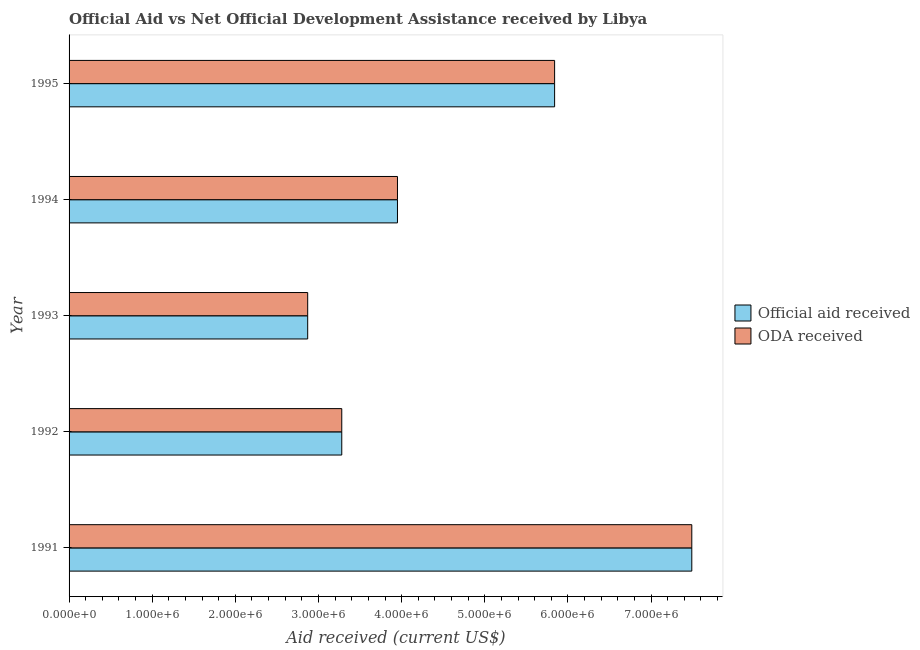How many groups of bars are there?
Give a very brief answer. 5. Are the number of bars per tick equal to the number of legend labels?
Your answer should be very brief. Yes. Are the number of bars on each tick of the Y-axis equal?
Your answer should be very brief. Yes. How many bars are there on the 3rd tick from the top?
Your answer should be very brief. 2. What is the oda received in 1995?
Offer a very short reply. 5.84e+06. Across all years, what is the maximum official aid received?
Ensure brevity in your answer.  7.49e+06. Across all years, what is the minimum official aid received?
Ensure brevity in your answer.  2.87e+06. In which year was the official aid received minimum?
Ensure brevity in your answer.  1993. What is the total official aid received in the graph?
Offer a very short reply. 2.34e+07. What is the difference between the oda received in 1993 and that in 1994?
Offer a terse response. -1.08e+06. What is the difference between the oda received in 1992 and the official aid received in 1993?
Give a very brief answer. 4.10e+05. What is the average official aid received per year?
Provide a succinct answer. 4.69e+06. In how many years, is the official aid received greater than 2400000 US$?
Keep it short and to the point. 5. What is the ratio of the official aid received in 1991 to that in 1992?
Provide a short and direct response. 2.28. What is the difference between the highest and the second highest oda received?
Keep it short and to the point. 1.65e+06. What is the difference between the highest and the lowest official aid received?
Your answer should be very brief. 4.62e+06. In how many years, is the oda received greater than the average oda received taken over all years?
Make the answer very short. 2. What does the 2nd bar from the top in 1993 represents?
Your answer should be very brief. Official aid received. What does the 2nd bar from the bottom in 1994 represents?
Ensure brevity in your answer.  ODA received. Are all the bars in the graph horizontal?
Offer a terse response. Yes. Are the values on the major ticks of X-axis written in scientific E-notation?
Offer a very short reply. Yes. Does the graph contain any zero values?
Keep it short and to the point. No. Does the graph contain grids?
Ensure brevity in your answer.  No. How many legend labels are there?
Your response must be concise. 2. What is the title of the graph?
Your answer should be very brief. Official Aid vs Net Official Development Assistance received by Libya . Does "By country of asylum" appear as one of the legend labels in the graph?
Your answer should be very brief. No. What is the label or title of the X-axis?
Your answer should be compact. Aid received (current US$). What is the label or title of the Y-axis?
Your response must be concise. Year. What is the Aid received (current US$) of Official aid received in 1991?
Give a very brief answer. 7.49e+06. What is the Aid received (current US$) in ODA received in 1991?
Give a very brief answer. 7.49e+06. What is the Aid received (current US$) of Official aid received in 1992?
Your response must be concise. 3.28e+06. What is the Aid received (current US$) in ODA received in 1992?
Provide a succinct answer. 3.28e+06. What is the Aid received (current US$) in Official aid received in 1993?
Offer a very short reply. 2.87e+06. What is the Aid received (current US$) of ODA received in 1993?
Keep it short and to the point. 2.87e+06. What is the Aid received (current US$) of Official aid received in 1994?
Give a very brief answer. 3.95e+06. What is the Aid received (current US$) in ODA received in 1994?
Ensure brevity in your answer.  3.95e+06. What is the Aid received (current US$) of Official aid received in 1995?
Your answer should be compact. 5.84e+06. What is the Aid received (current US$) of ODA received in 1995?
Keep it short and to the point. 5.84e+06. Across all years, what is the maximum Aid received (current US$) in Official aid received?
Your response must be concise. 7.49e+06. Across all years, what is the maximum Aid received (current US$) of ODA received?
Provide a succinct answer. 7.49e+06. Across all years, what is the minimum Aid received (current US$) of Official aid received?
Offer a very short reply. 2.87e+06. Across all years, what is the minimum Aid received (current US$) of ODA received?
Make the answer very short. 2.87e+06. What is the total Aid received (current US$) of Official aid received in the graph?
Your answer should be very brief. 2.34e+07. What is the total Aid received (current US$) of ODA received in the graph?
Your answer should be very brief. 2.34e+07. What is the difference between the Aid received (current US$) in Official aid received in 1991 and that in 1992?
Your answer should be very brief. 4.21e+06. What is the difference between the Aid received (current US$) in ODA received in 1991 and that in 1992?
Offer a very short reply. 4.21e+06. What is the difference between the Aid received (current US$) in Official aid received in 1991 and that in 1993?
Provide a succinct answer. 4.62e+06. What is the difference between the Aid received (current US$) in ODA received in 1991 and that in 1993?
Your answer should be very brief. 4.62e+06. What is the difference between the Aid received (current US$) of Official aid received in 1991 and that in 1994?
Offer a very short reply. 3.54e+06. What is the difference between the Aid received (current US$) of ODA received in 1991 and that in 1994?
Ensure brevity in your answer.  3.54e+06. What is the difference between the Aid received (current US$) of Official aid received in 1991 and that in 1995?
Give a very brief answer. 1.65e+06. What is the difference between the Aid received (current US$) in ODA received in 1991 and that in 1995?
Make the answer very short. 1.65e+06. What is the difference between the Aid received (current US$) in Official aid received in 1992 and that in 1994?
Provide a succinct answer. -6.70e+05. What is the difference between the Aid received (current US$) in ODA received in 1992 and that in 1994?
Keep it short and to the point. -6.70e+05. What is the difference between the Aid received (current US$) in Official aid received in 1992 and that in 1995?
Your answer should be very brief. -2.56e+06. What is the difference between the Aid received (current US$) in ODA received in 1992 and that in 1995?
Make the answer very short. -2.56e+06. What is the difference between the Aid received (current US$) of Official aid received in 1993 and that in 1994?
Provide a succinct answer. -1.08e+06. What is the difference between the Aid received (current US$) of ODA received in 1993 and that in 1994?
Keep it short and to the point. -1.08e+06. What is the difference between the Aid received (current US$) of Official aid received in 1993 and that in 1995?
Give a very brief answer. -2.97e+06. What is the difference between the Aid received (current US$) in ODA received in 1993 and that in 1995?
Your answer should be very brief. -2.97e+06. What is the difference between the Aid received (current US$) of Official aid received in 1994 and that in 1995?
Provide a short and direct response. -1.89e+06. What is the difference between the Aid received (current US$) of ODA received in 1994 and that in 1995?
Offer a very short reply. -1.89e+06. What is the difference between the Aid received (current US$) of Official aid received in 1991 and the Aid received (current US$) of ODA received in 1992?
Provide a short and direct response. 4.21e+06. What is the difference between the Aid received (current US$) in Official aid received in 1991 and the Aid received (current US$) in ODA received in 1993?
Ensure brevity in your answer.  4.62e+06. What is the difference between the Aid received (current US$) in Official aid received in 1991 and the Aid received (current US$) in ODA received in 1994?
Your answer should be very brief. 3.54e+06. What is the difference between the Aid received (current US$) in Official aid received in 1991 and the Aid received (current US$) in ODA received in 1995?
Offer a terse response. 1.65e+06. What is the difference between the Aid received (current US$) of Official aid received in 1992 and the Aid received (current US$) of ODA received in 1994?
Provide a succinct answer. -6.70e+05. What is the difference between the Aid received (current US$) of Official aid received in 1992 and the Aid received (current US$) of ODA received in 1995?
Your answer should be compact. -2.56e+06. What is the difference between the Aid received (current US$) of Official aid received in 1993 and the Aid received (current US$) of ODA received in 1994?
Give a very brief answer. -1.08e+06. What is the difference between the Aid received (current US$) of Official aid received in 1993 and the Aid received (current US$) of ODA received in 1995?
Your answer should be very brief. -2.97e+06. What is the difference between the Aid received (current US$) in Official aid received in 1994 and the Aid received (current US$) in ODA received in 1995?
Offer a very short reply. -1.89e+06. What is the average Aid received (current US$) of Official aid received per year?
Offer a very short reply. 4.69e+06. What is the average Aid received (current US$) of ODA received per year?
Your answer should be very brief. 4.69e+06. In the year 1991, what is the difference between the Aid received (current US$) in Official aid received and Aid received (current US$) in ODA received?
Give a very brief answer. 0. In the year 1993, what is the difference between the Aid received (current US$) of Official aid received and Aid received (current US$) of ODA received?
Give a very brief answer. 0. In the year 1995, what is the difference between the Aid received (current US$) of Official aid received and Aid received (current US$) of ODA received?
Offer a terse response. 0. What is the ratio of the Aid received (current US$) in Official aid received in 1991 to that in 1992?
Ensure brevity in your answer.  2.28. What is the ratio of the Aid received (current US$) in ODA received in 1991 to that in 1992?
Offer a very short reply. 2.28. What is the ratio of the Aid received (current US$) of Official aid received in 1991 to that in 1993?
Offer a very short reply. 2.61. What is the ratio of the Aid received (current US$) of ODA received in 1991 to that in 1993?
Provide a short and direct response. 2.61. What is the ratio of the Aid received (current US$) in Official aid received in 1991 to that in 1994?
Ensure brevity in your answer.  1.9. What is the ratio of the Aid received (current US$) in ODA received in 1991 to that in 1994?
Your response must be concise. 1.9. What is the ratio of the Aid received (current US$) in Official aid received in 1991 to that in 1995?
Your answer should be very brief. 1.28. What is the ratio of the Aid received (current US$) in ODA received in 1991 to that in 1995?
Ensure brevity in your answer.  1.28. What is the ratio of the Aid received (current US$) of Official aid received in 1992 to that in 1993?
Make the answer very short. 1.14. What is the ratio of the Aid received (current US$) in ODA received in 1992 to that in 1993?
Your answer should be very brief. 1.14. What is the ratio of the Aid received (current US$) of Official aid received in 1992 to that in 1994?
Your answer should be compact. 0.83. What is the ratio of the Aid received (current US$) of ODA received in 1992 to that in 1994?
Give a very brief answer. 0.83. What is the ratio of the Aid received (current US$) of Official aid received in 1992 to that in 1995?
Give a very brief answer. 0.56. What is the ratio of the Aid received (current US$) in ODA received in 1992 to that in 1995?
Make the answer very short. 0.56. What is the ratio of the Aid received (current US$) in Official aid received in 1993 to that in 1994?
Provide a short and direct response. 0.73. What is the ratio of the Aid received (current US$) of ODA received in 1993 to that in 1994?
Provide a succinct answer. 0.73. What is the ratio of the Aid received (current US$) in Official aid received in 1993 to that in 1995?
Your answer should be very brief. 0.49. What is the ratio of the Aid received (current US$) in ODA received in 1993 to that in 1995?
Offer a terse response. 0.49. What is the ratio of the Aid received (current US$) of Official aid received in 1994 to that in 1995?
Offer a terse response. 0.68. What is the ratio of the Aid received (current US$) in ODA received in 1994 to that in 1995?
Give a very brief answer. 0.68. What is the difference between the highest and the second highest Aid received (current US$) of Official aid received?
Offer a terse response. 1.65e+06. What is the difference between the highest and the second highest Aid received (current US$) in ODA received?
Keep it short and to the point. 1.65e+06. What is the difference between the highest and the lowest Aid received (current US$) in Official aid received?
Give a very brief answer. 4.62e+06. What is the difference between the highest and the lowest Aid received (current US$) in ODA received?
Your response must be concise. 4.62e+06. 